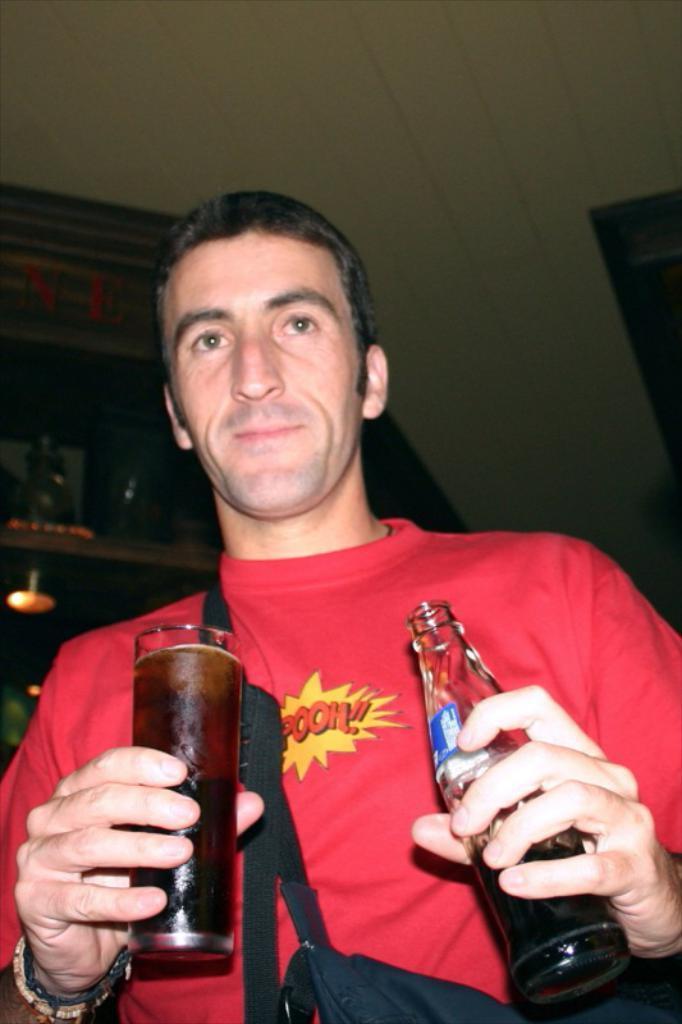How would you summarize this image in a sentence or two? In picture a person is holding a glass and a bottle with the liquid in it we can also see a shelf near to him and a light in the shelf. 